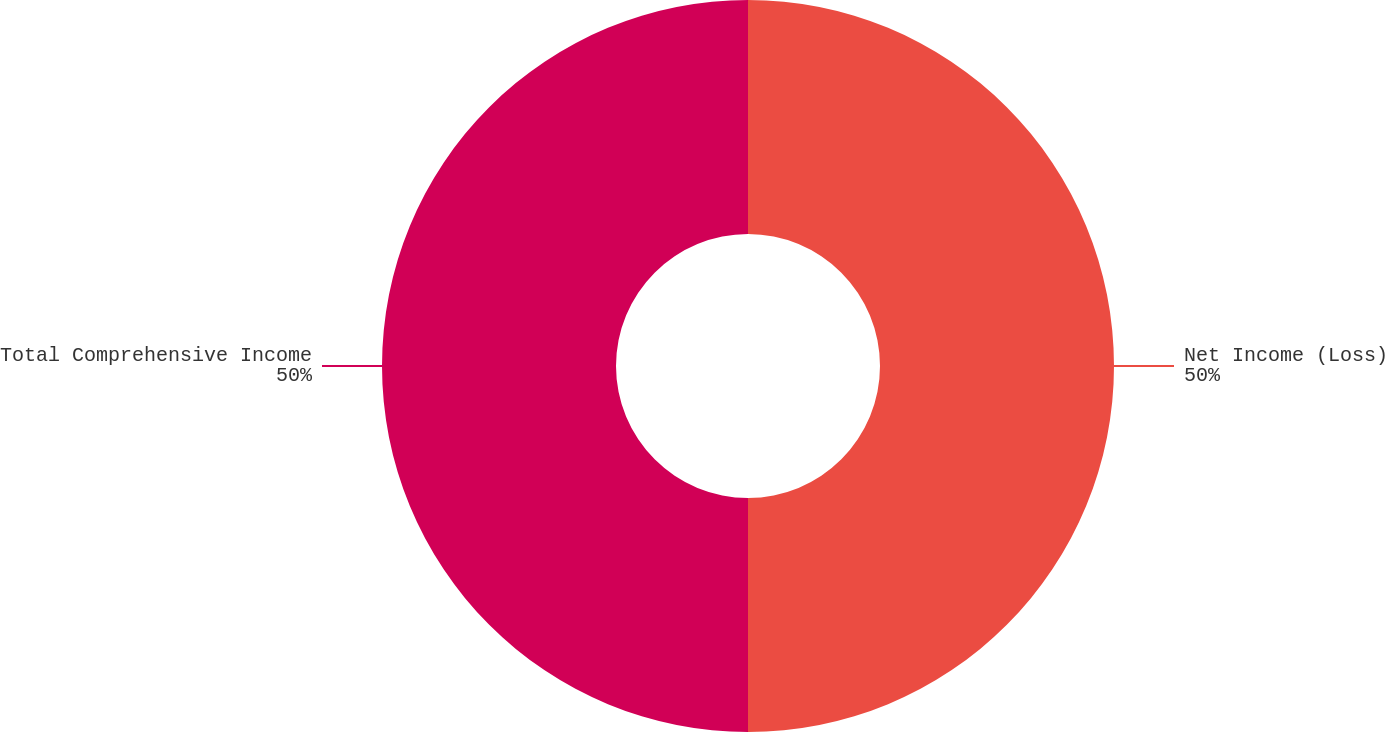Convert chart to OTSL. <chart><loc_0><loc_0><loc_500><loc_500><pie_chart><fcel>Net Income (Loss)<fcel>Total Comprehensive Income<nl><fcel>50.0%<fcel>50.0%<nl></chart> 